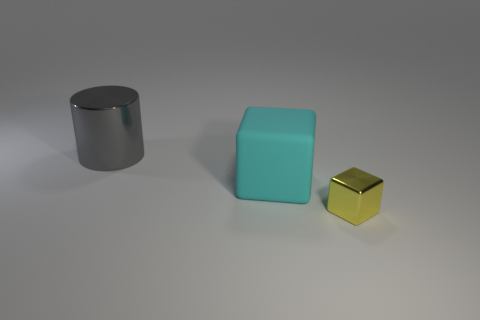There is a cube behind the yellow shiny block; is its size the same as the big cylinder?
Ensure brevity in your answer.  Yes. What number of other objects are the same shape as the big shiny thing?
Give a very brief answer. 0. Do the thing that is on the right side of the large cyan rubber thing and the matte object have the same color?
Your response must be concise. No. Are there any tiny metallic blocks of the same color as the large matte thing?
Offer a terse response. No. There is a rubber thing; how many tiny objects are on the right side of it?
Give a very brief answer. 1. How many other objects are there of the same size as the cyan matte cube?
Offer a terse response. 1. Does the block behind the yellow metallic cube have the same material as the object behind the cyan matte thing?
Make the answer very short. No. The metal cylinder that is the same size as the cyan thing is what color?
Keep it short and to the point. Gray. Is there any other thing of the same color as the large metallic thing?
Your answer should be compact. No. How big is the cube that is behind the metallic thing that is to the right of the big object that is right of the large gray metal object?
Make the answer very short. Large. 